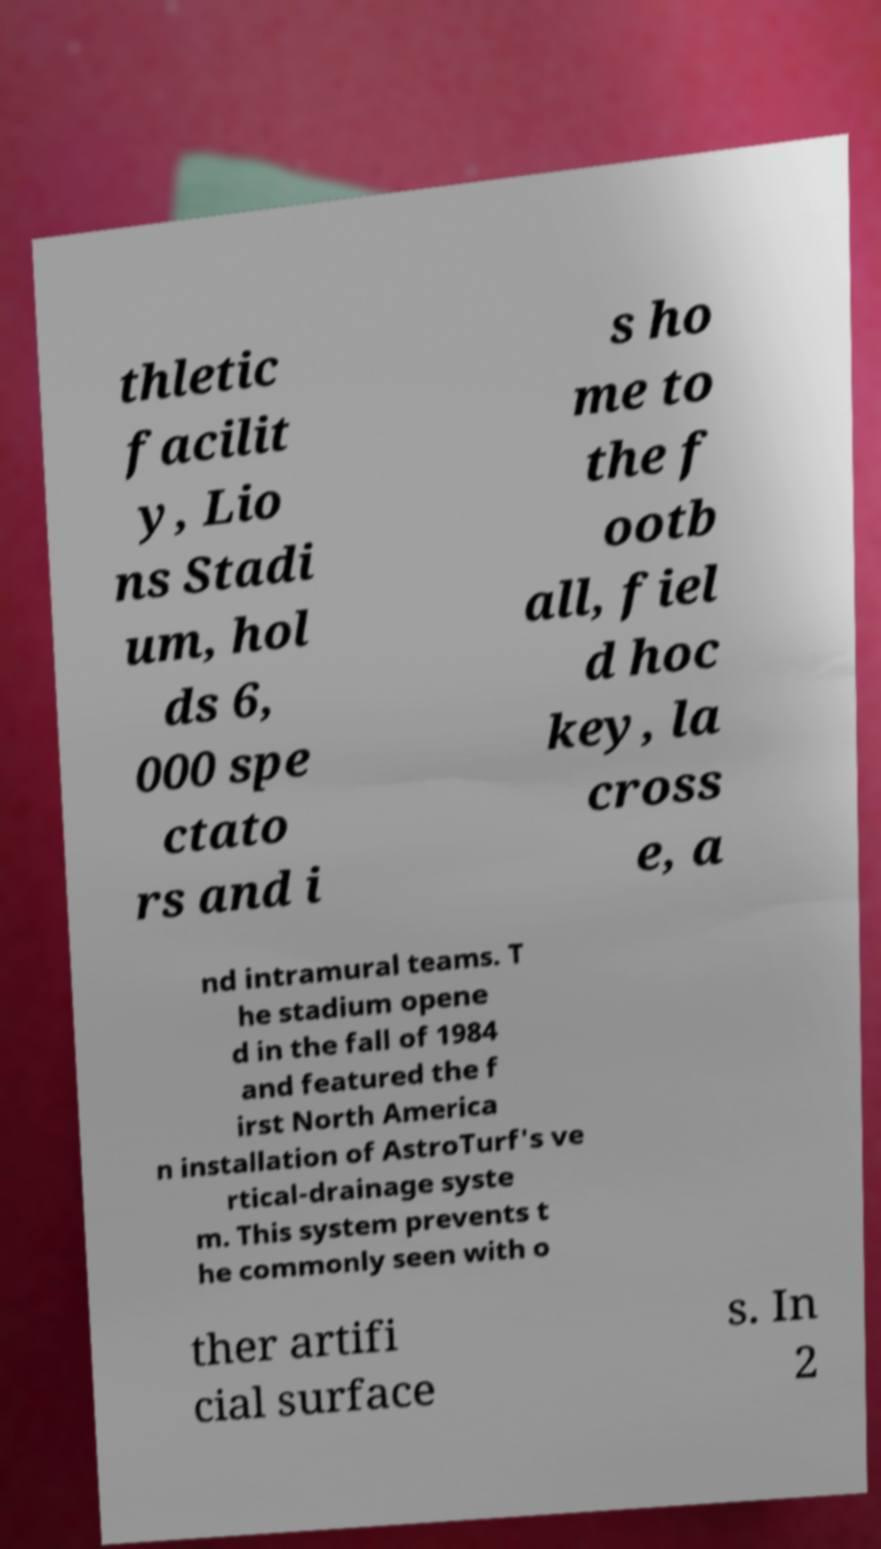Can you read and provide the text displayed in the image?This photo seems to have some interesting text. Can you extract and type it out for me? thletic facilit y, Lio ns Stadi um, hol ds 6, 000 spe ctato rs and i s ho me to the f ootb all, fiel d hoc key, la cross e, a nd intramural teams. T he stadium opene d in the fall of 1984 and featured the f irst North America n installation of AstroTurf's ve rtical-drainage syste m. This system prevents t he commonly seen with o ther artifi cial surface s. In 2 